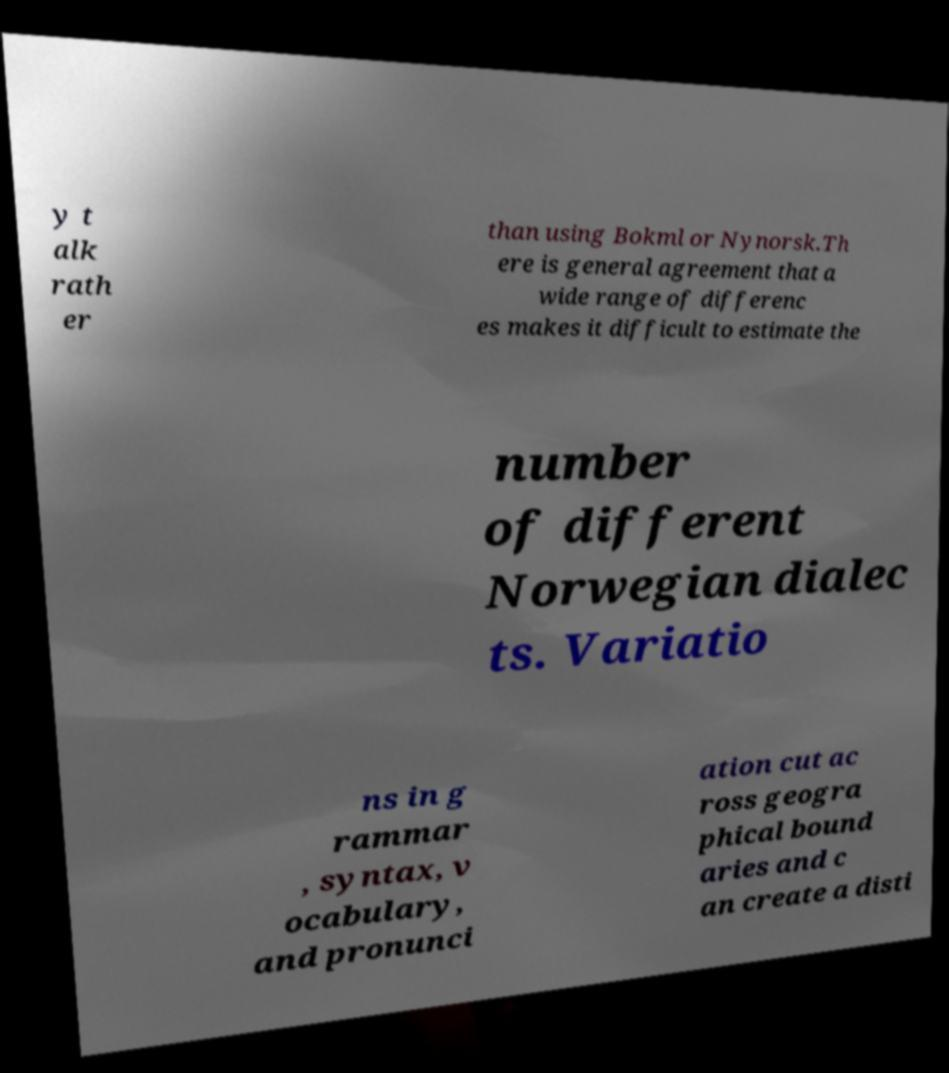What messages or text are displayed in this image? I need them in a readable, typed format. y t alk rath er than using Bokml or Nynorsk.Th ere is general agreement that a wide range of differenc es makes it difficult to estimate the number of different Norwegian dialec ts. Variatio ns in g rammar , syntax, v ocabulary, and pronunci ation cut ac ross geogra phical bound aries and c an create a disti 